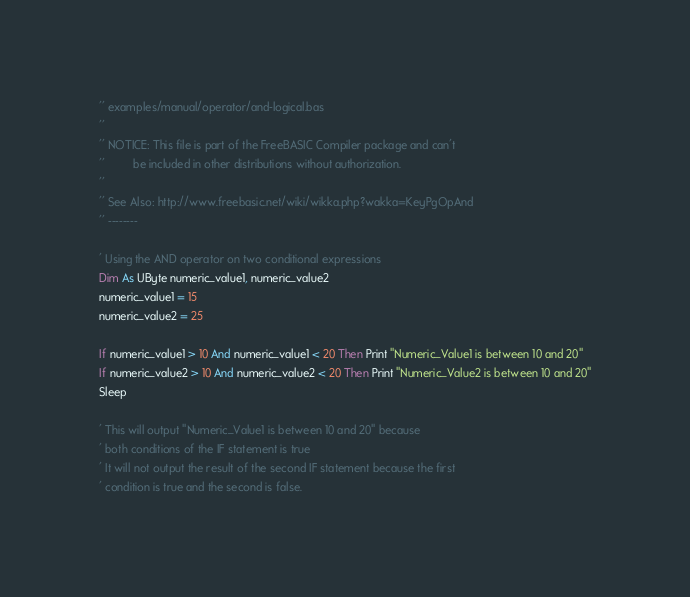Convert code to text. <code><loc_0><loc_0><loc_500><loc_500><_VisualBasic_>'' examples/manual/operator/and-logical.bas
''
'' NOTICE: This file is part of the FreeBASIC Compiler package and can't
''         be included in other distributions without authorization.
''
'' See Also: http://www.freebasic.net/wiki/wikka.php?wakka=KeyPgOpAnd
'' --------

' Using the AND operator on two conditional expressions
Dim As UByte numeric_value1, numeric_value2
numeric_value1 = 15
numeric_value2 = 25

If numeric_value1 > 10 And numeric_value1 < 20 Then Print "Numeric_Value1 is between 10 and 20"
If numeric_value2 > 10 And numeric_value2 < 20 Then Print "Numeric_Value2 is between 10 and 20"
Sleep

' This will output "Numeric_Value1 is between 10 and 20" because
' both conditions of the IF statement is true
' It will not output the result of the second IF statement because the first
' condition is true and the second is false.
</code> 